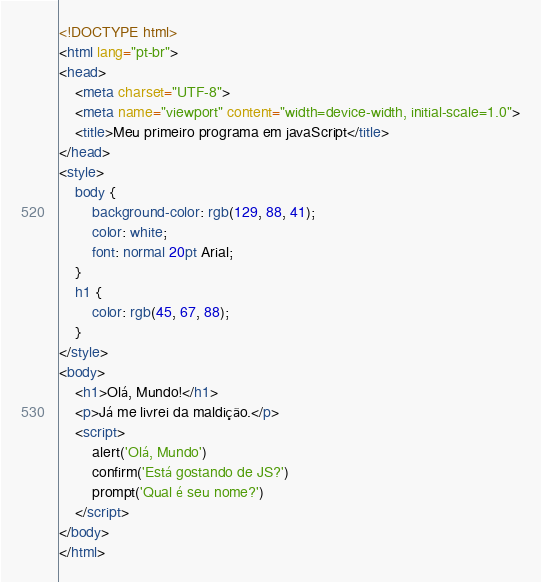<code> <loc_0><loc_0><loc_500><loc_500><_HTML_><!DOCTYPE html>
<html lang="pt-br">
<head>
    <meta charset="UTF-8">
    <meta name="viewport" content="width=device-width, initial-scale=1.0">
    <title>Meu primeiro programa em javaScript</title>
</head>
<style>
    body {
        background-color: rgb(129, 88, 41);
        color: white;
        font: normal 20pt Arial;
    }
    h1 {
        color: rgb(45, 67, 88);
    }
</style>
<body>
    <h1>Olá, Mundo!</h1>
    <p>Já me livrei da maldição.</p>
    <script>
        alert('Olá, Mundo')
        confirm('Está gostando de JS?')
        prompt('Qual é seu nome?')
    </script>
</body>
</html></code> 